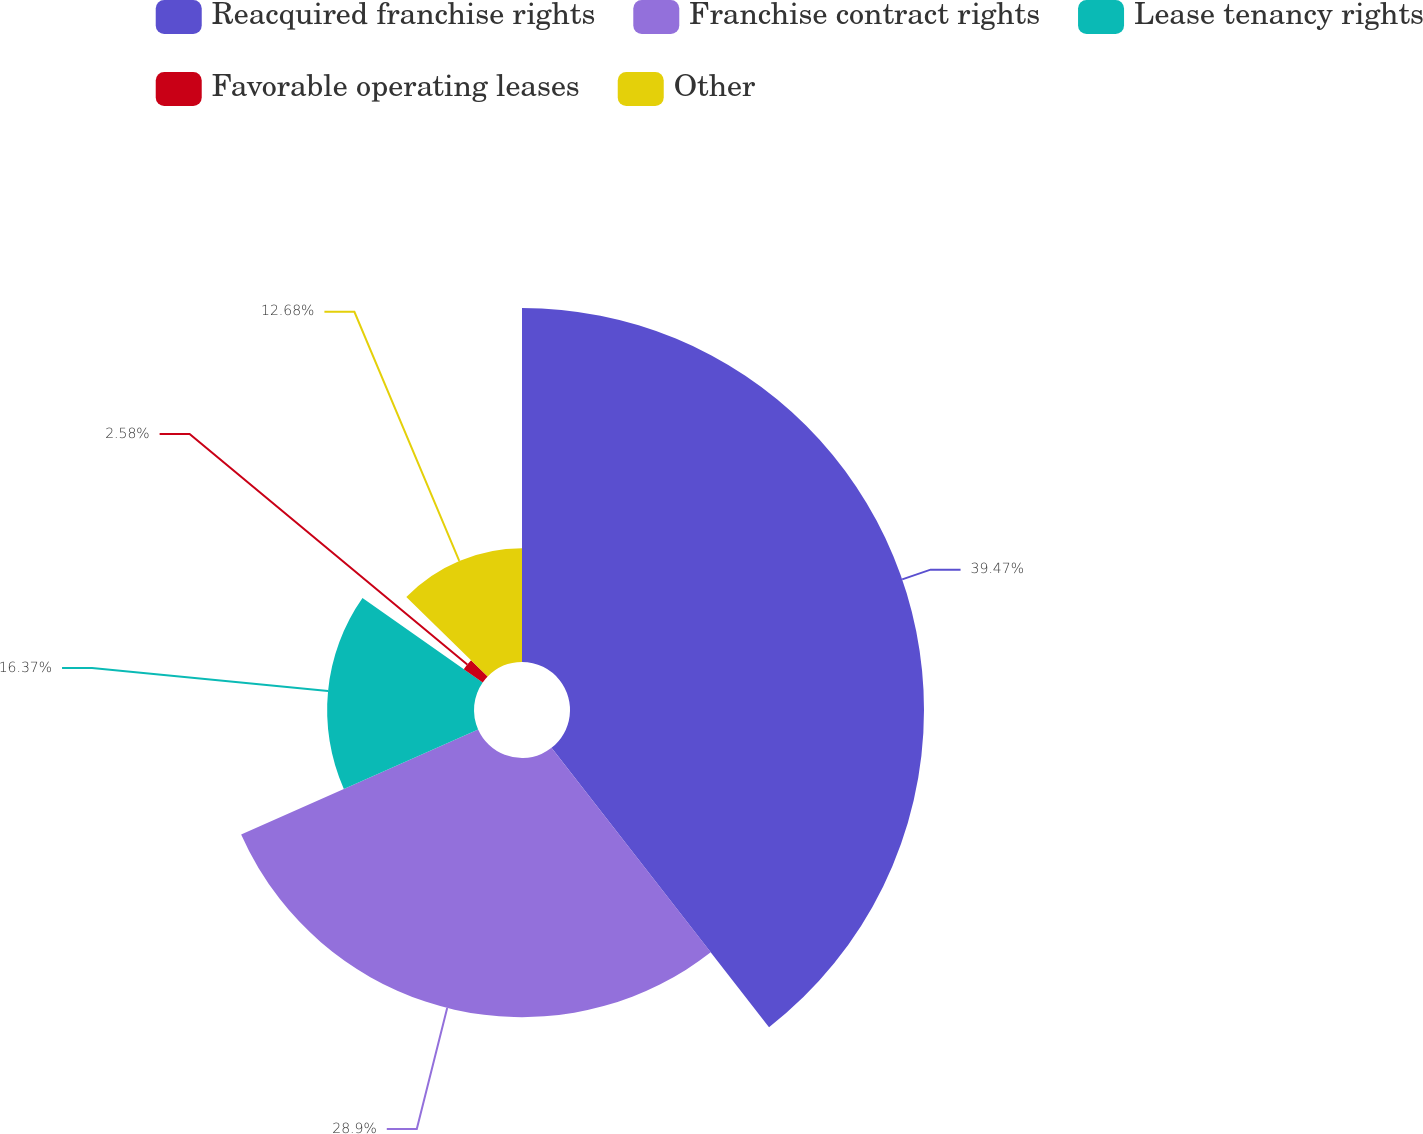<chart> <loc_0><loc_0><loc_500><loc_500><pie_chart><fcel>Reacquired franchise rights<fcel>Franchise contract rights<fcel>Lease tenancy rights<fcel>Favorable operating leases<fcel>Other<nl><fcel>39.46%<fcel>28.89%<fcel>16.37%<fcel>2.58%<fcel>12.68%<nl></chart> 